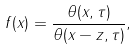Convert formula to latex. <formula><loc_0><loc_0><loc_500><loc_500>f ( x ) = \frac { \theta ( x , \tau ) } { \theta ( x - z , \tau ) } ,</formula> 